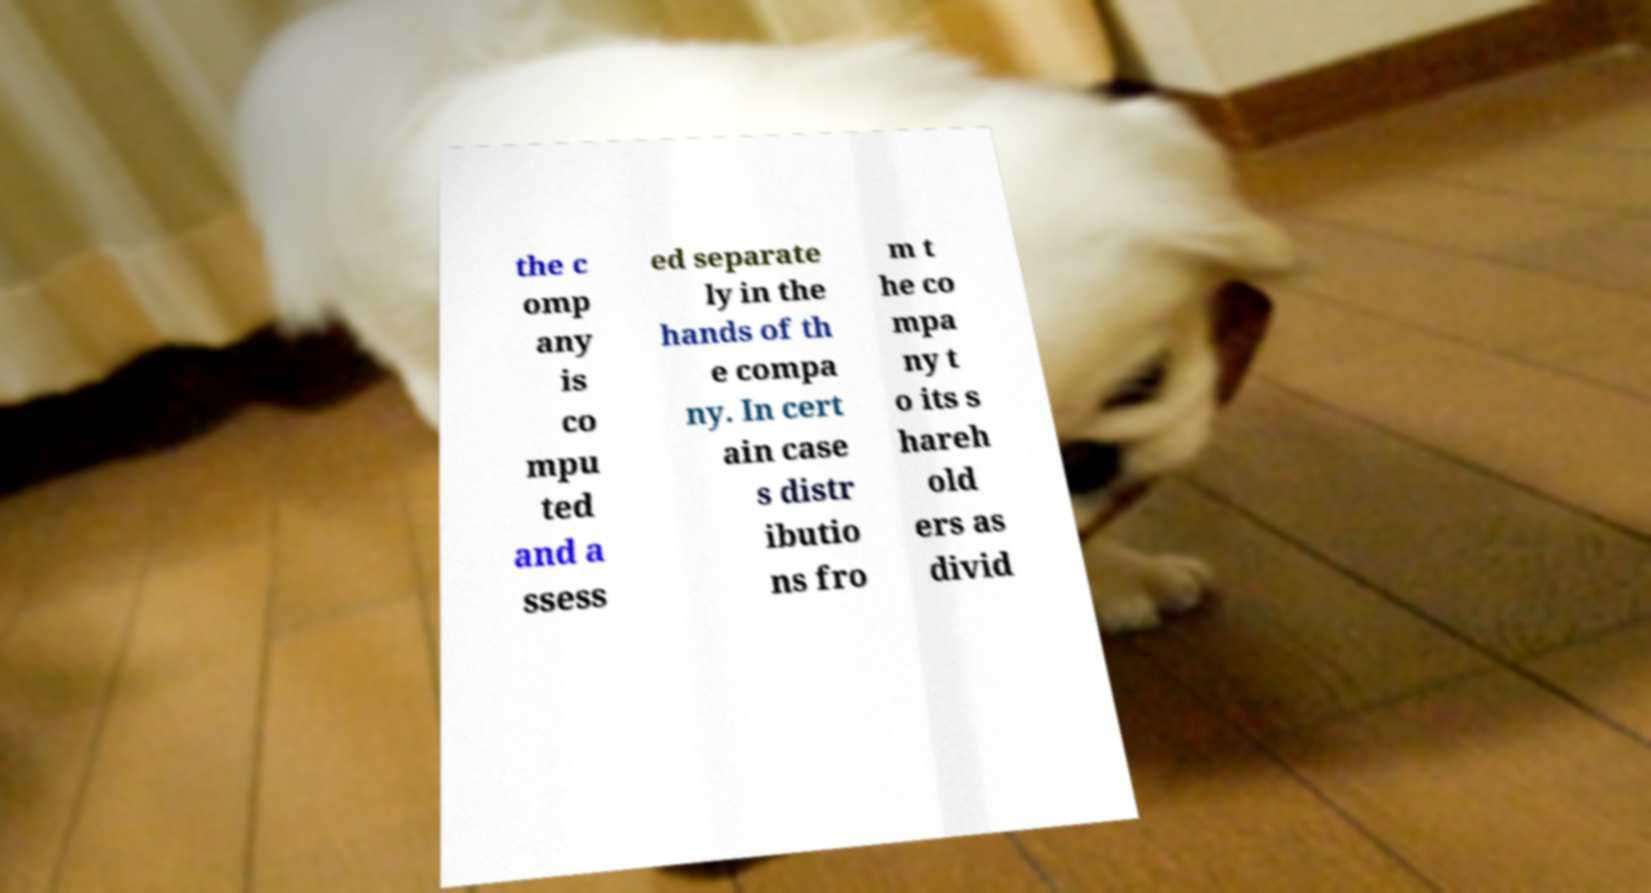Could you extract and type out the text from this image? the c omp any is co mpu ted and a ssess ed separate ly in the hands of th e compa ny. In cert ain case s distr ibutio ns fro m t he co mpa ny t o its s hareh old ers as divid 